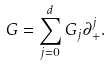<formula> <loc_0><loc_0><loc_500><loc_500>G = \sum _ { j = 0 } ^ { d } G _ { j } \partial _ { + } ^ { j } .</formula> 